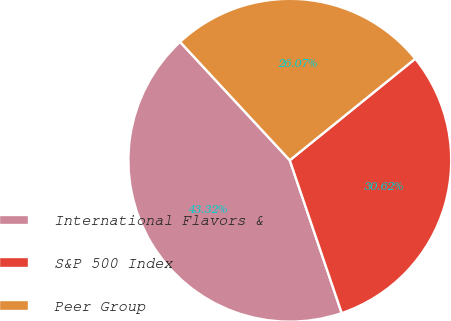Convert chart to OTSL. <chart><loc_0><loc_0><loc_500><loc_500><pie_chart><fcel>International Flavors &<fcel>S&P 500 Index<fcel>Peer Group<nl><fcel>43.32%<fcel>30.62%<fcel>26.07%<nl></chart> 